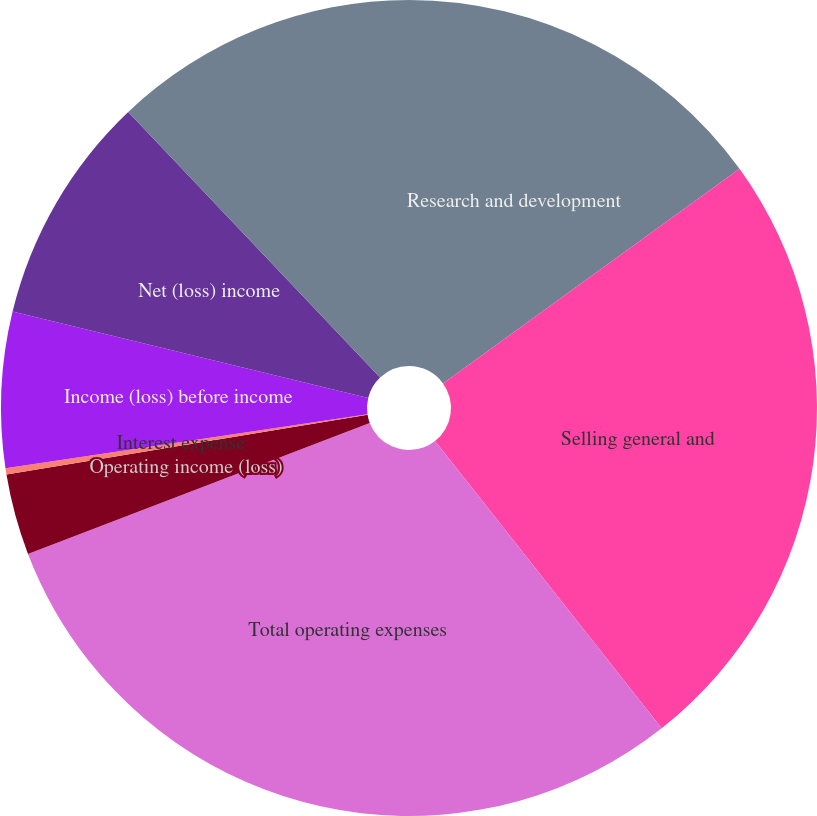<chart> <loc_0><loc_0><loc_500><loc_500><pie_chart><fcel>Research and development<fcel>Selling general and<fcel>Total operating expenses<fcel>Operating income (loss)<fcel>Interest expense<fcel>Income (loss) before income<fcel>Net (loss) income<fcel>Comprehensive (loss) income<nl><fcel>15.03%<fcel>24.34%<fcel>29.81%<fcel>3.21%<fcel>0.25%<fcel>6.16%<fcel>9.12%<fcel>12.08%<nl></chart> 